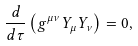<formula> <loc_0><loc_0><loc_500><loc_500>\frac { d } { d \tau } \left ( g ^ { \mu \nu } Y _ { \mu } Y _ { \nu } \right ) = 0 ,</formula> 